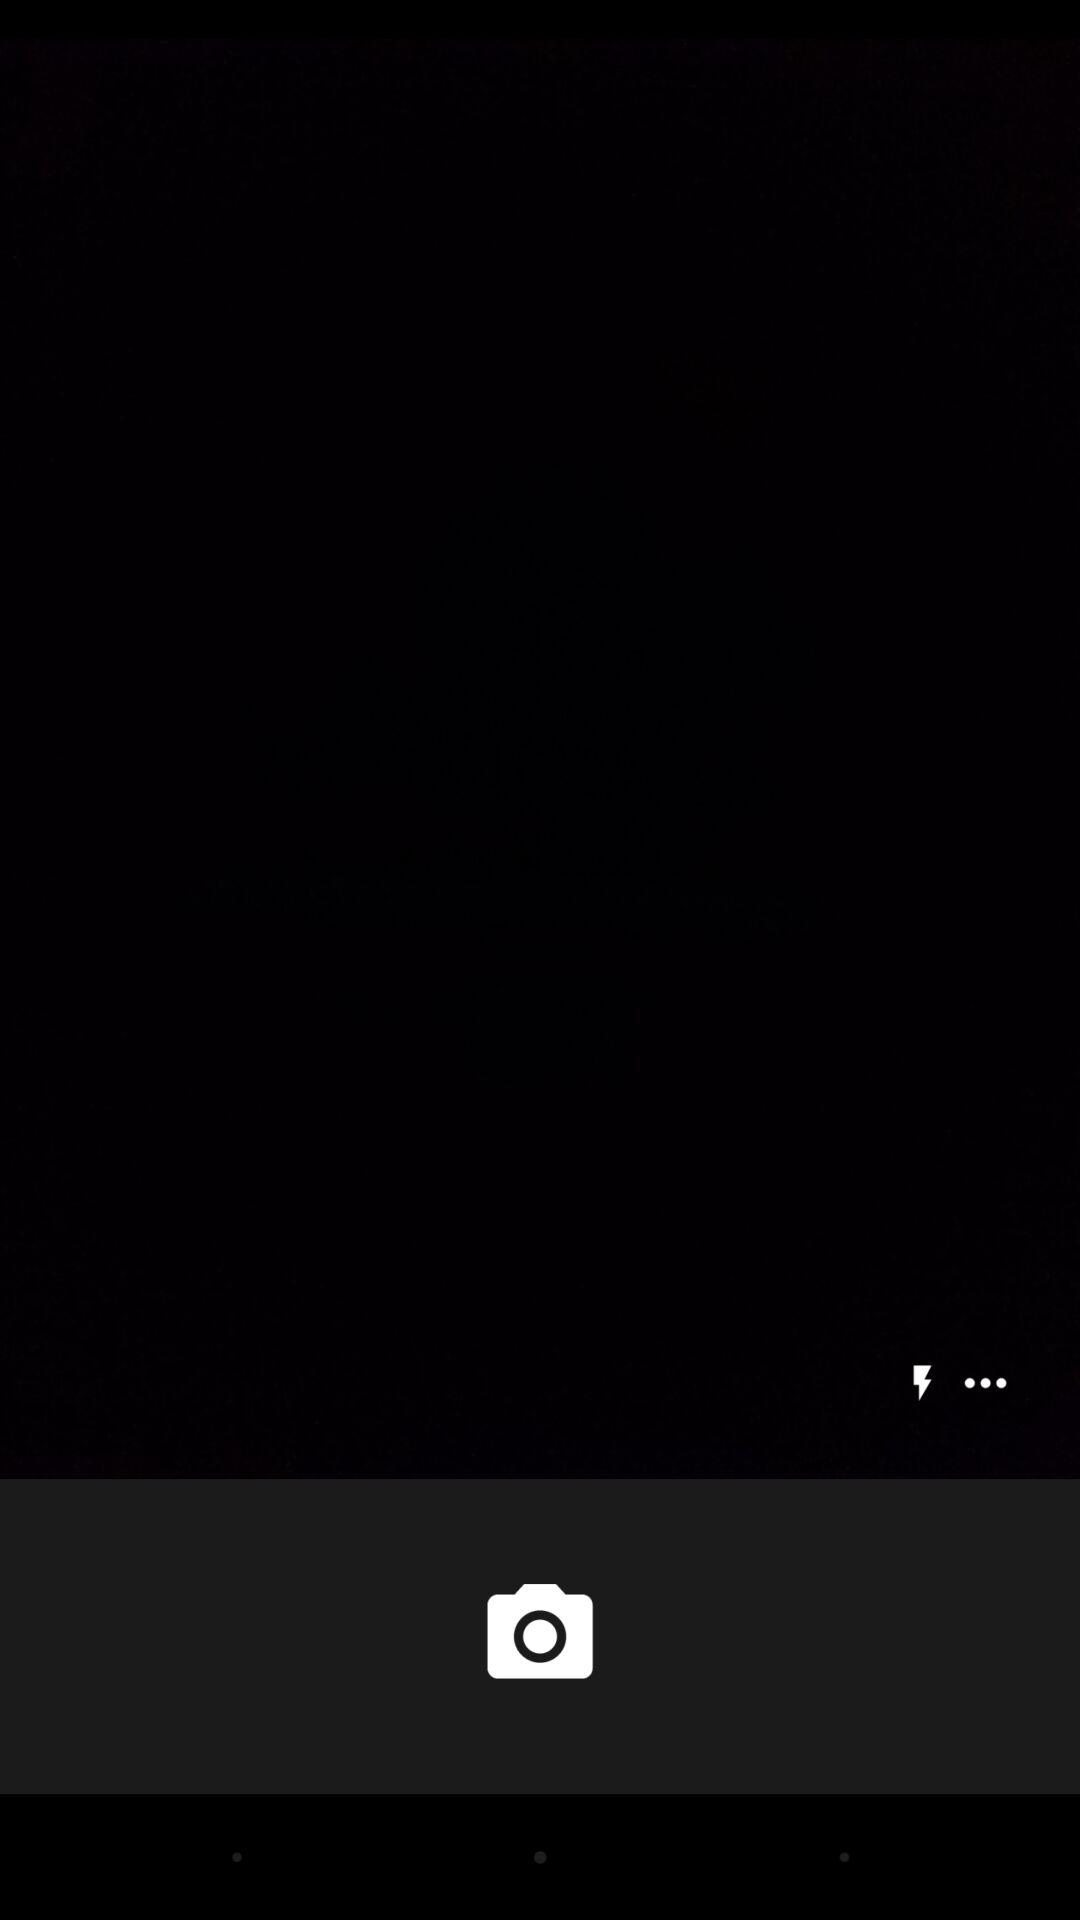How many more dots are there than lightning bolts on the screen?
Answer the question using a single word or phrase. 2 